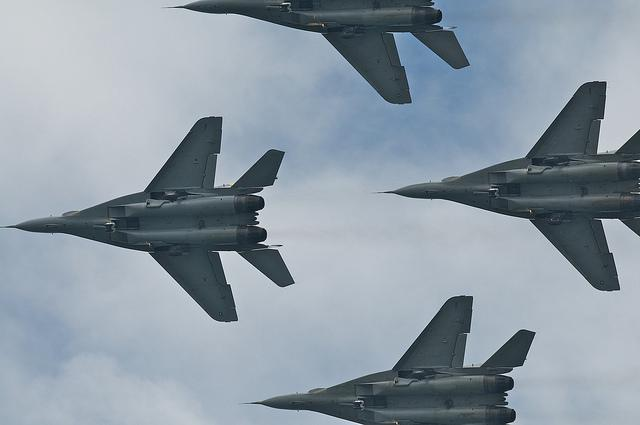The number of items visible in the sky cane be referred to as what? quad 